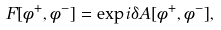<formula> <loc_0><loc_0><loc_500><loc_500>F [ \phi ^ { + } , \phi ^ { - } ] = \exp { i \delta A [ \phi ^ { + } , \phi ^ { - } ] } ,</formula> 